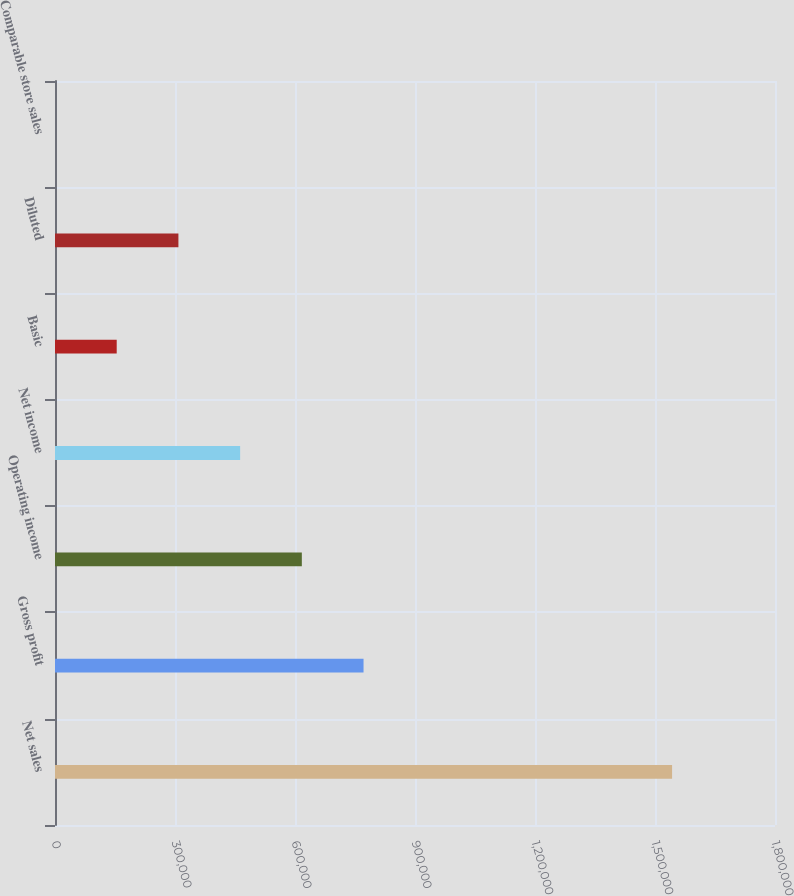<chart> <loc_0><loc_0><loc_500><loc_500><bar_chart><fcel>Net sales<fcel>Gross profit<fcel>Operating income<fcel>Net income<fcel>Basic<fcel>Diluted<fcel>Comparable store sales<nl><fcel>1.54271e+06<fcel>771353<fcel>617083<fcel>462812<fcel>154271<fcel>308542<fcel>0.6<nl></chart> 